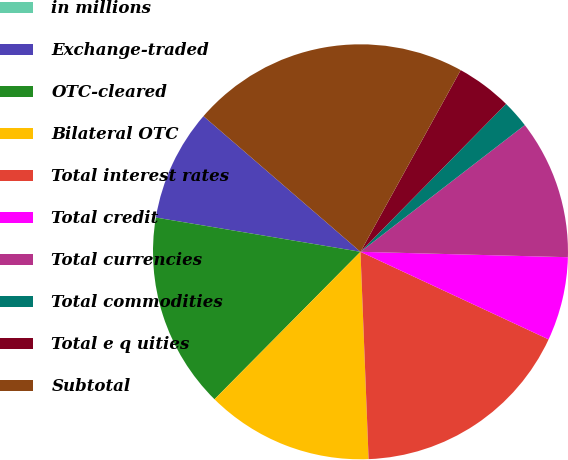Convert chart to OTSL. <chart><loc_0><loc_0><loc_500><loc_500><pie_chart><fcel>in millions<fcel>Exchange-traded<fcel>OTC-cleared<fcel>Bilateral OTC<fcel>Total interest rates<fcel>Total credit<fcel>Total currencies<fcel>Total commodities<fcel>Total e q uities<fcel>Subtotal<nl><fcel>0.0%<fcel>8.7%<fcel>15.22%<fcel>13.04%<fcel>17.44%<fcel>6.52%<fcel>10.87%<fcel>2.17%<fcel>4.35%<fcel>21.68%<nl></chart> 